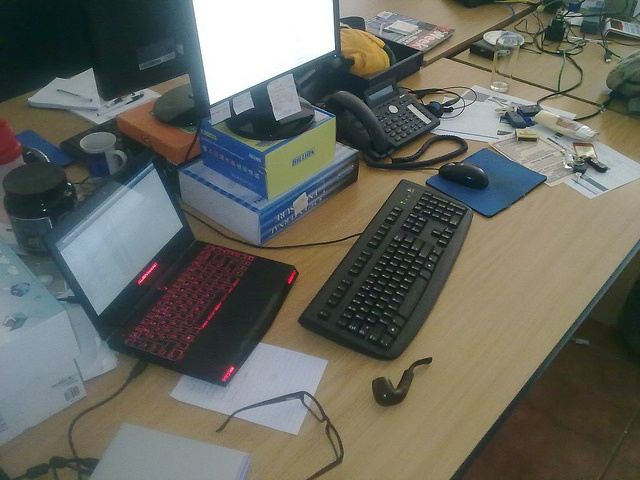Describe the objects in this image and their specific colors. I can see laptop in black, darkgray, maroon, and blue tones, keyboard in black and gray tones, tv in black, white, gray, and darkgray tones, book in black, gray, and blue tones, and keyboard in black, maroon, purple, and brown tones in this image. 